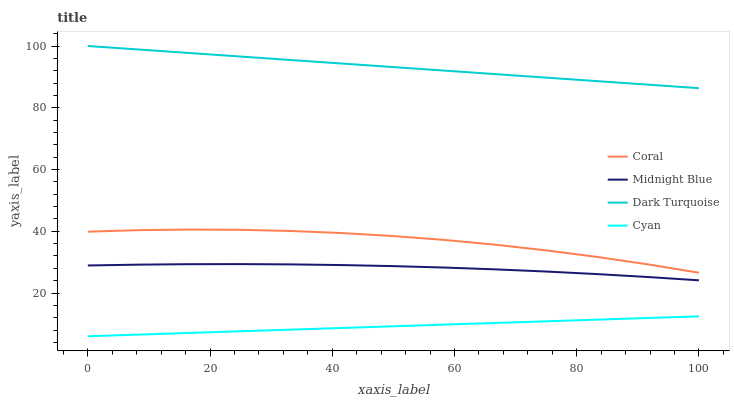Does Coral have the minimum area under the curve?
Answer yes or no. No. Does Coral have the maximum area under the curve?
Answer yes or no. No. Is Midnight Blue the smoothest?
Answer yes or no. No. Is Midnight Blue the roughest?
Answer yes or no. No. Does Coral have the lowest value?
Answer yes or no. No. Does Coral have the highest value?
Answer yes or no. No. Is Cyan less than Dark Turquoise?
Answer yes or no. Yes. Is Midnight Blue greater than Cyan?
Answer yes or no. Yes. Does Cyan intersect Dark Turquoise?
Answer yes or no. No. 